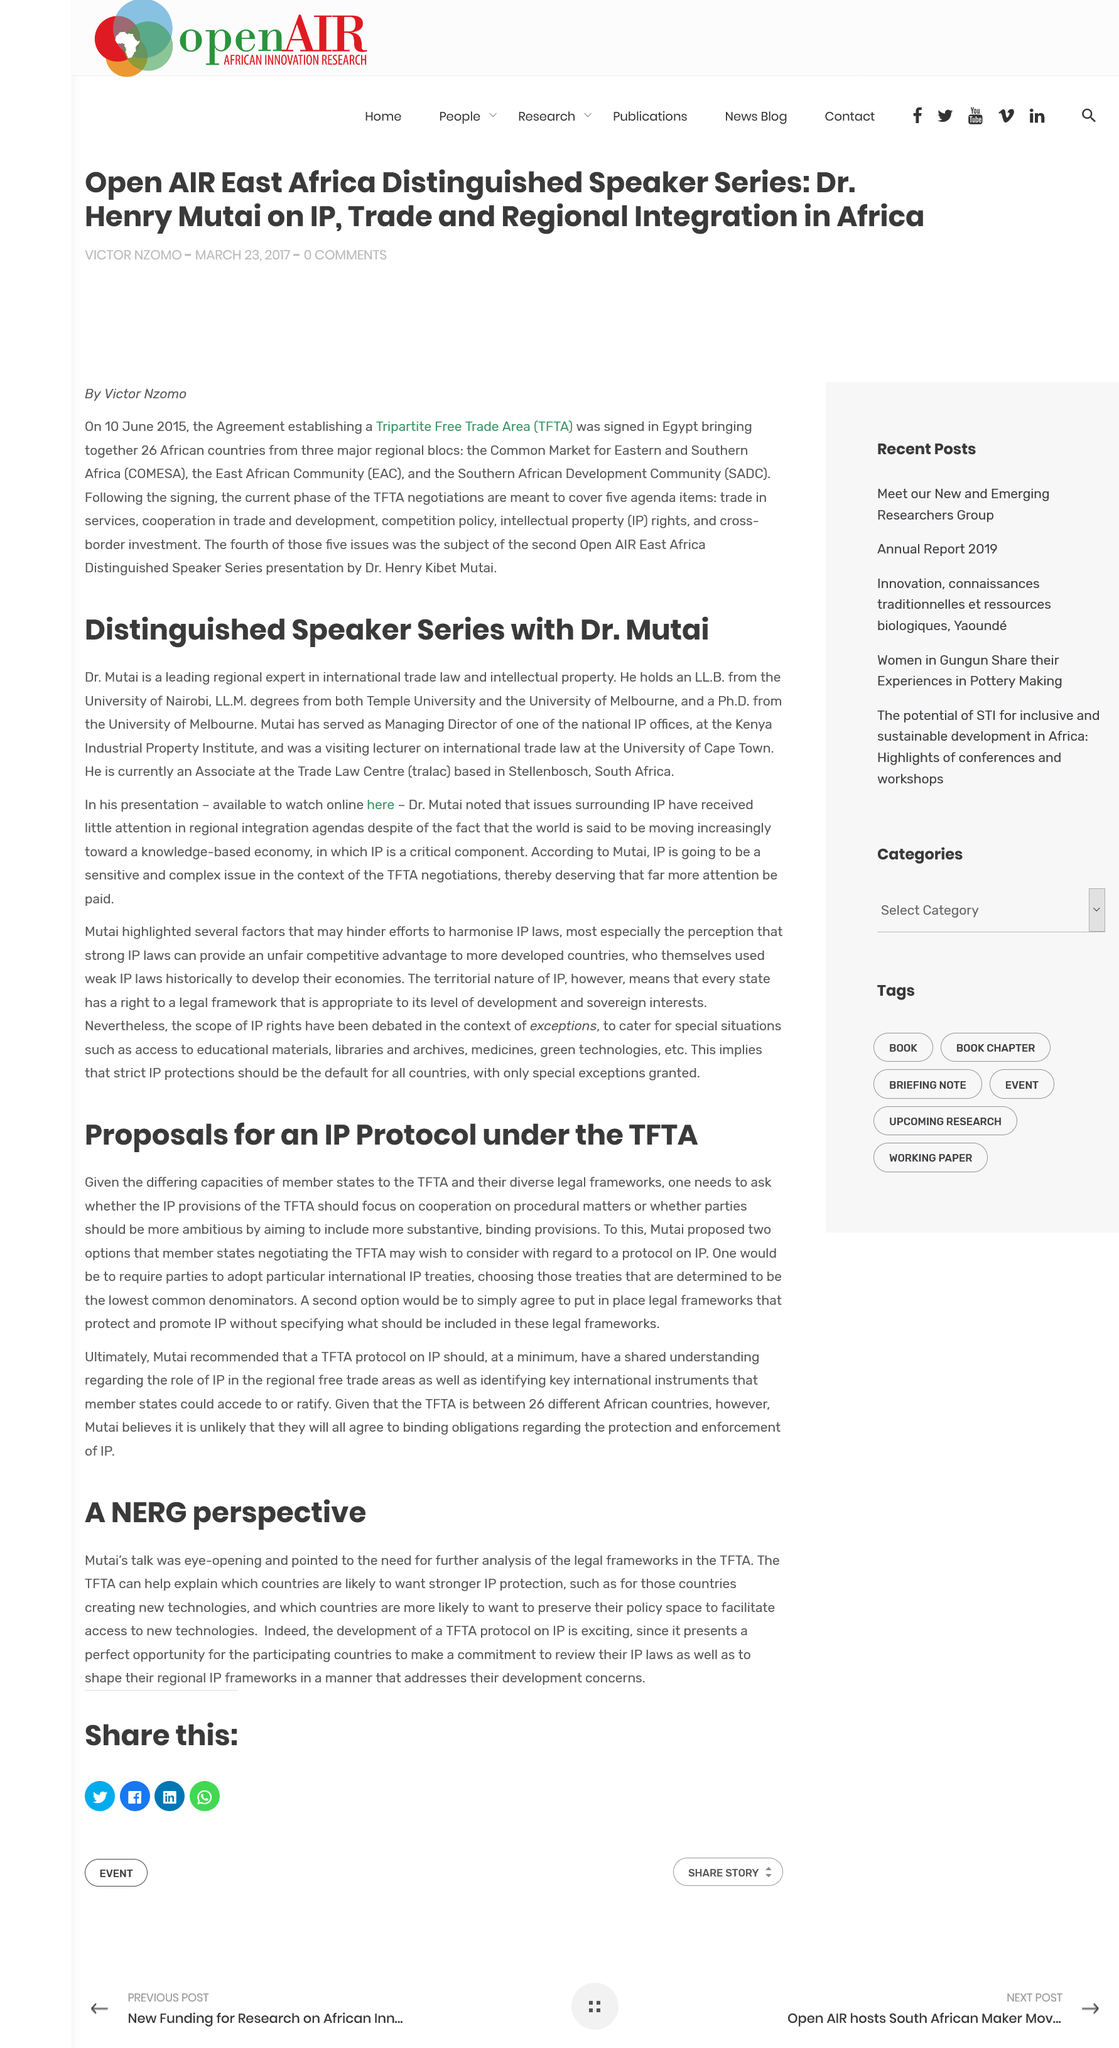Draw attention to some important aspects in this diagram. The text refers to the NERG perspective. This article discusses proposals for a new IP protocol under the TFTA (Tripartite Free Trade Area). Mutai proposed two options. The Trans-Pacific Trade Agreement (TFTA) can help to explain the relationships between trade, investment, and intellectual property rights protection in countries that are likely to seek stronger IP protection such as the United States, Japan, and Australia. According to Dr. Mutai, intellectual property is expected to be a sensitive and complex issue in the future. 